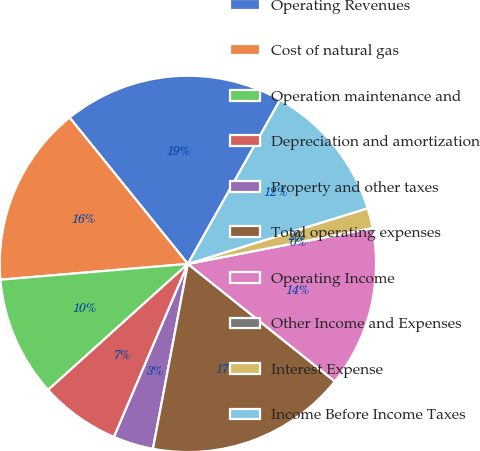Convert chart to OTSL. <chart><loc_0><loc_0><loc_500><loc_500><pie_chart><fcel>Operating Revenues<fcel>Cost of natural gas<fcel>Operation maintenance and<fcel>Depreciation and amortization<fcel>Property and other taxes<fcel>Total operating expenses<fcel>Operating Income<fcel>Other Income and Expenses<fcel>Interest Expense<fcel>Income Before Income Taxes<nl><fcel>18.97%<fcel>15.52%<fcel>10.34%<fcel>6.9%<fcel>3.45%<fcel>17.24%<fcel>13.79%<fcel>0.0%<fcel>1.72%<fcel>12.07%<nl></chart> 